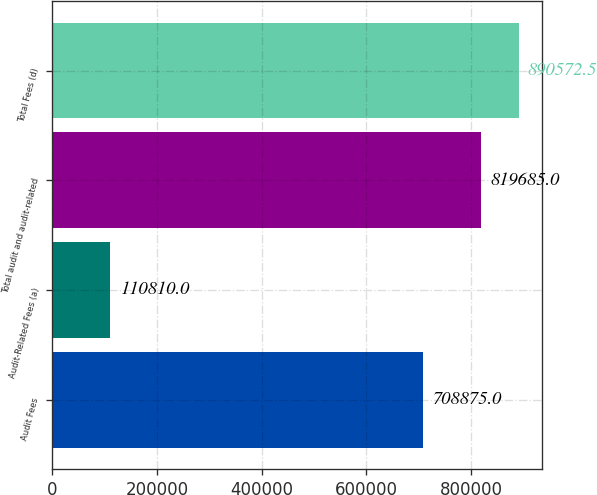Convert chart. <chart><loc_0><loc_0><loc_500><loc_500><bar_chart><fcel>Audit Fees<fcel>Audit-Related Fees (a)<fcel>Total audit and audit-related<fcel>Total Fees (d)<nl><fcel>708875<fcel>110810<fcel>819685<fcel>890572<nl></chart> 